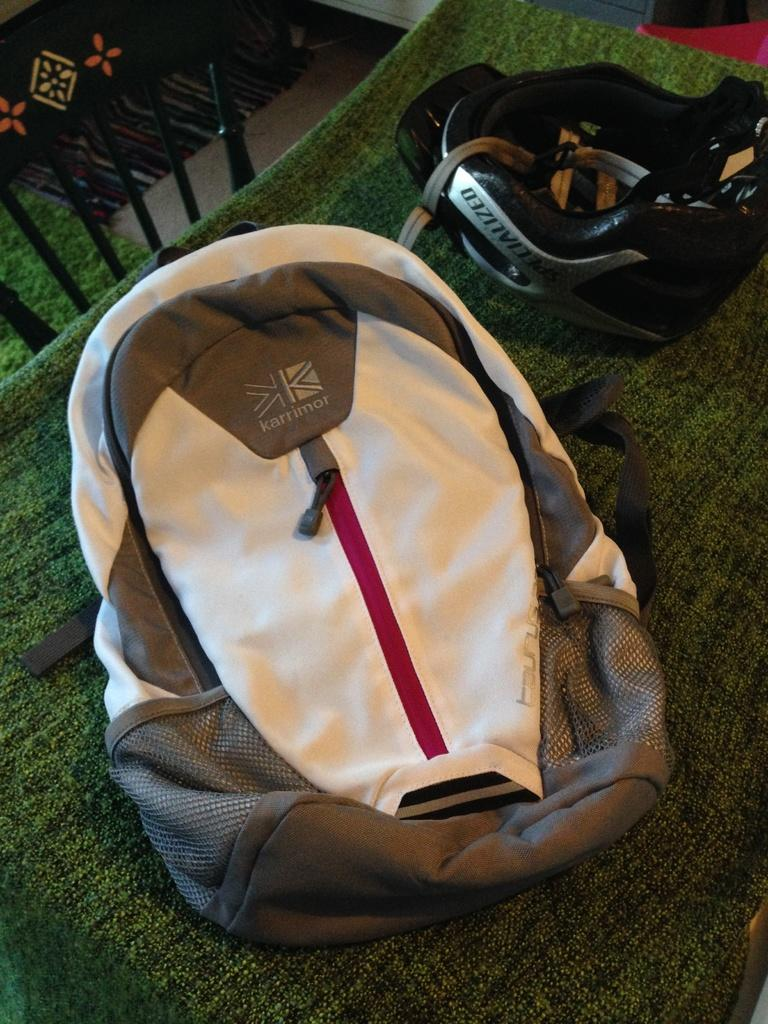What type of furniture is present in the image? There is a table in the image. What is covering the table? The table is covered with a green cloth. Is there any seating near the table? Yes, there is a chair beside the table. What items can be seen on the table? A bag and a helmet are placed on the table. How many eyes can be seen on the frogs in the image? There are no frogs present in the image, so the number of eyes cannot be determined. 